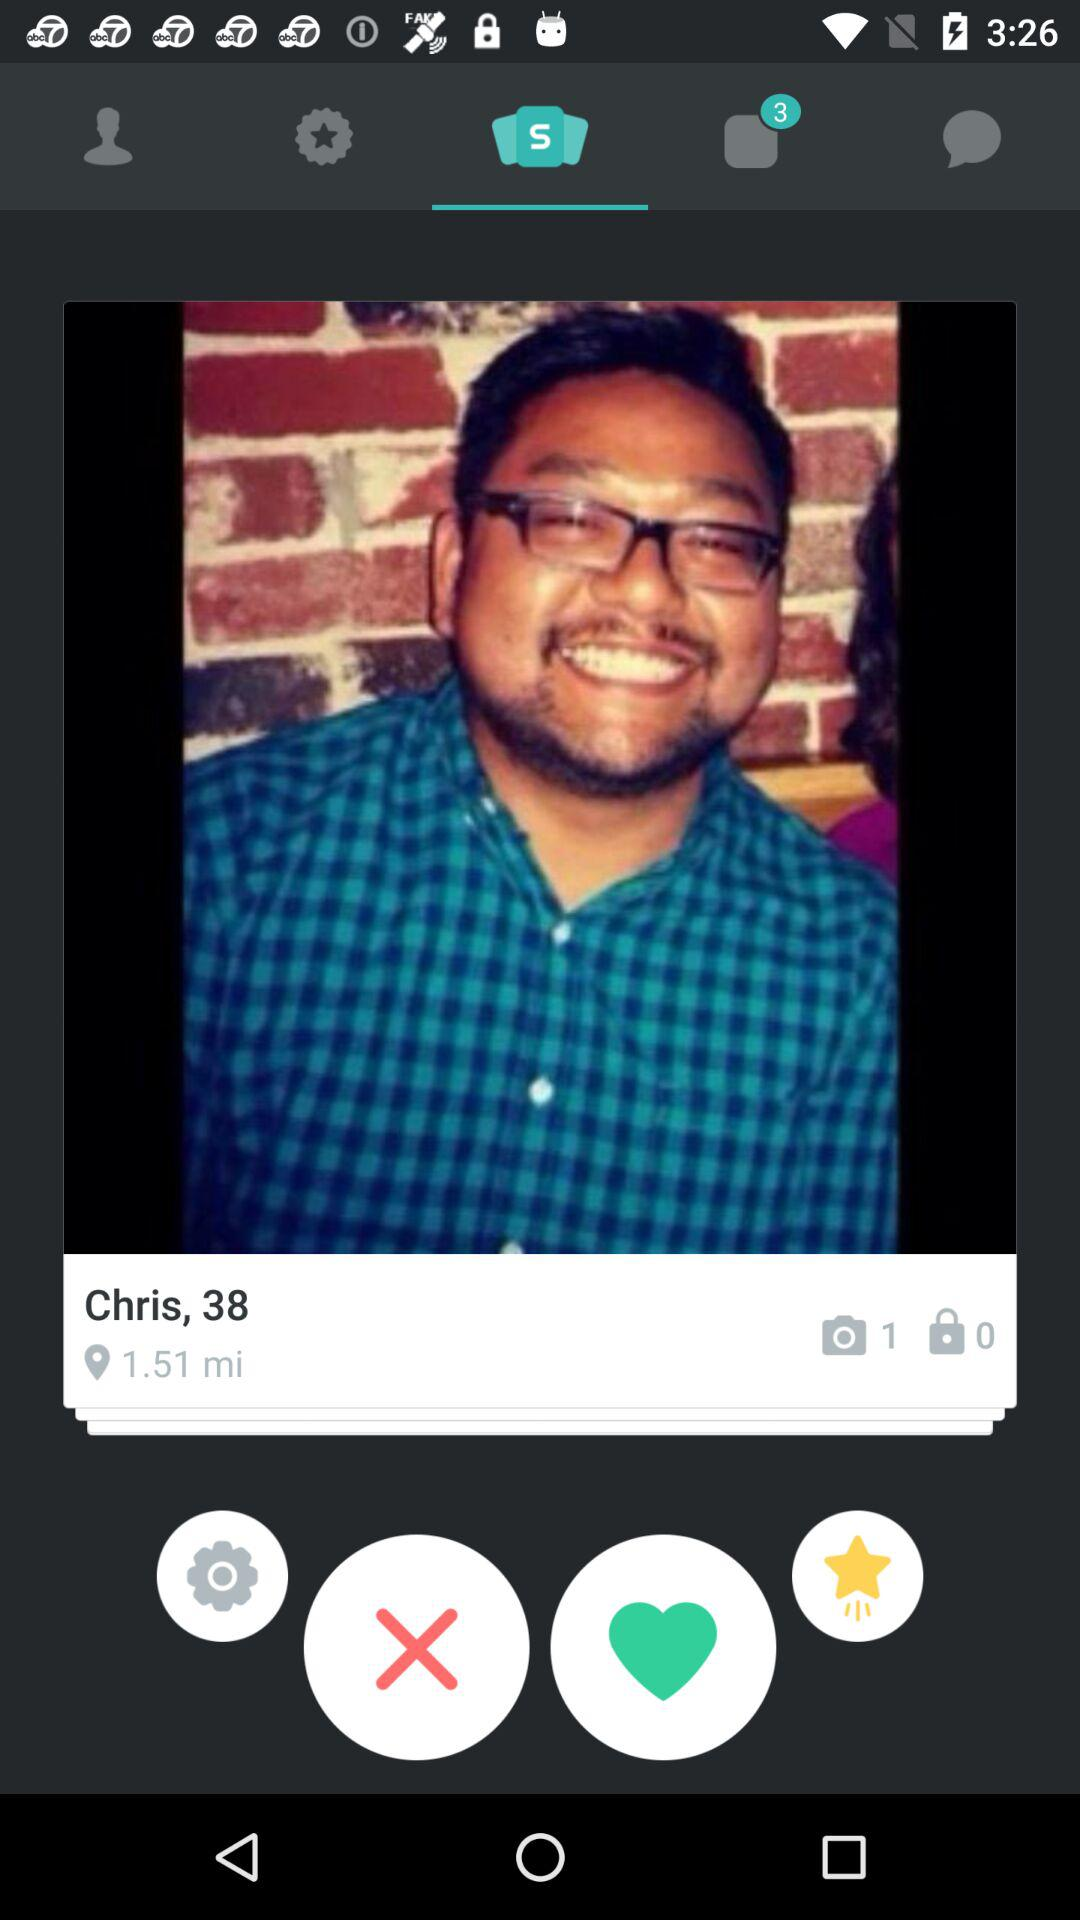How many miles away is Chris?
Answer the question using a single word or phrase. 1.51 